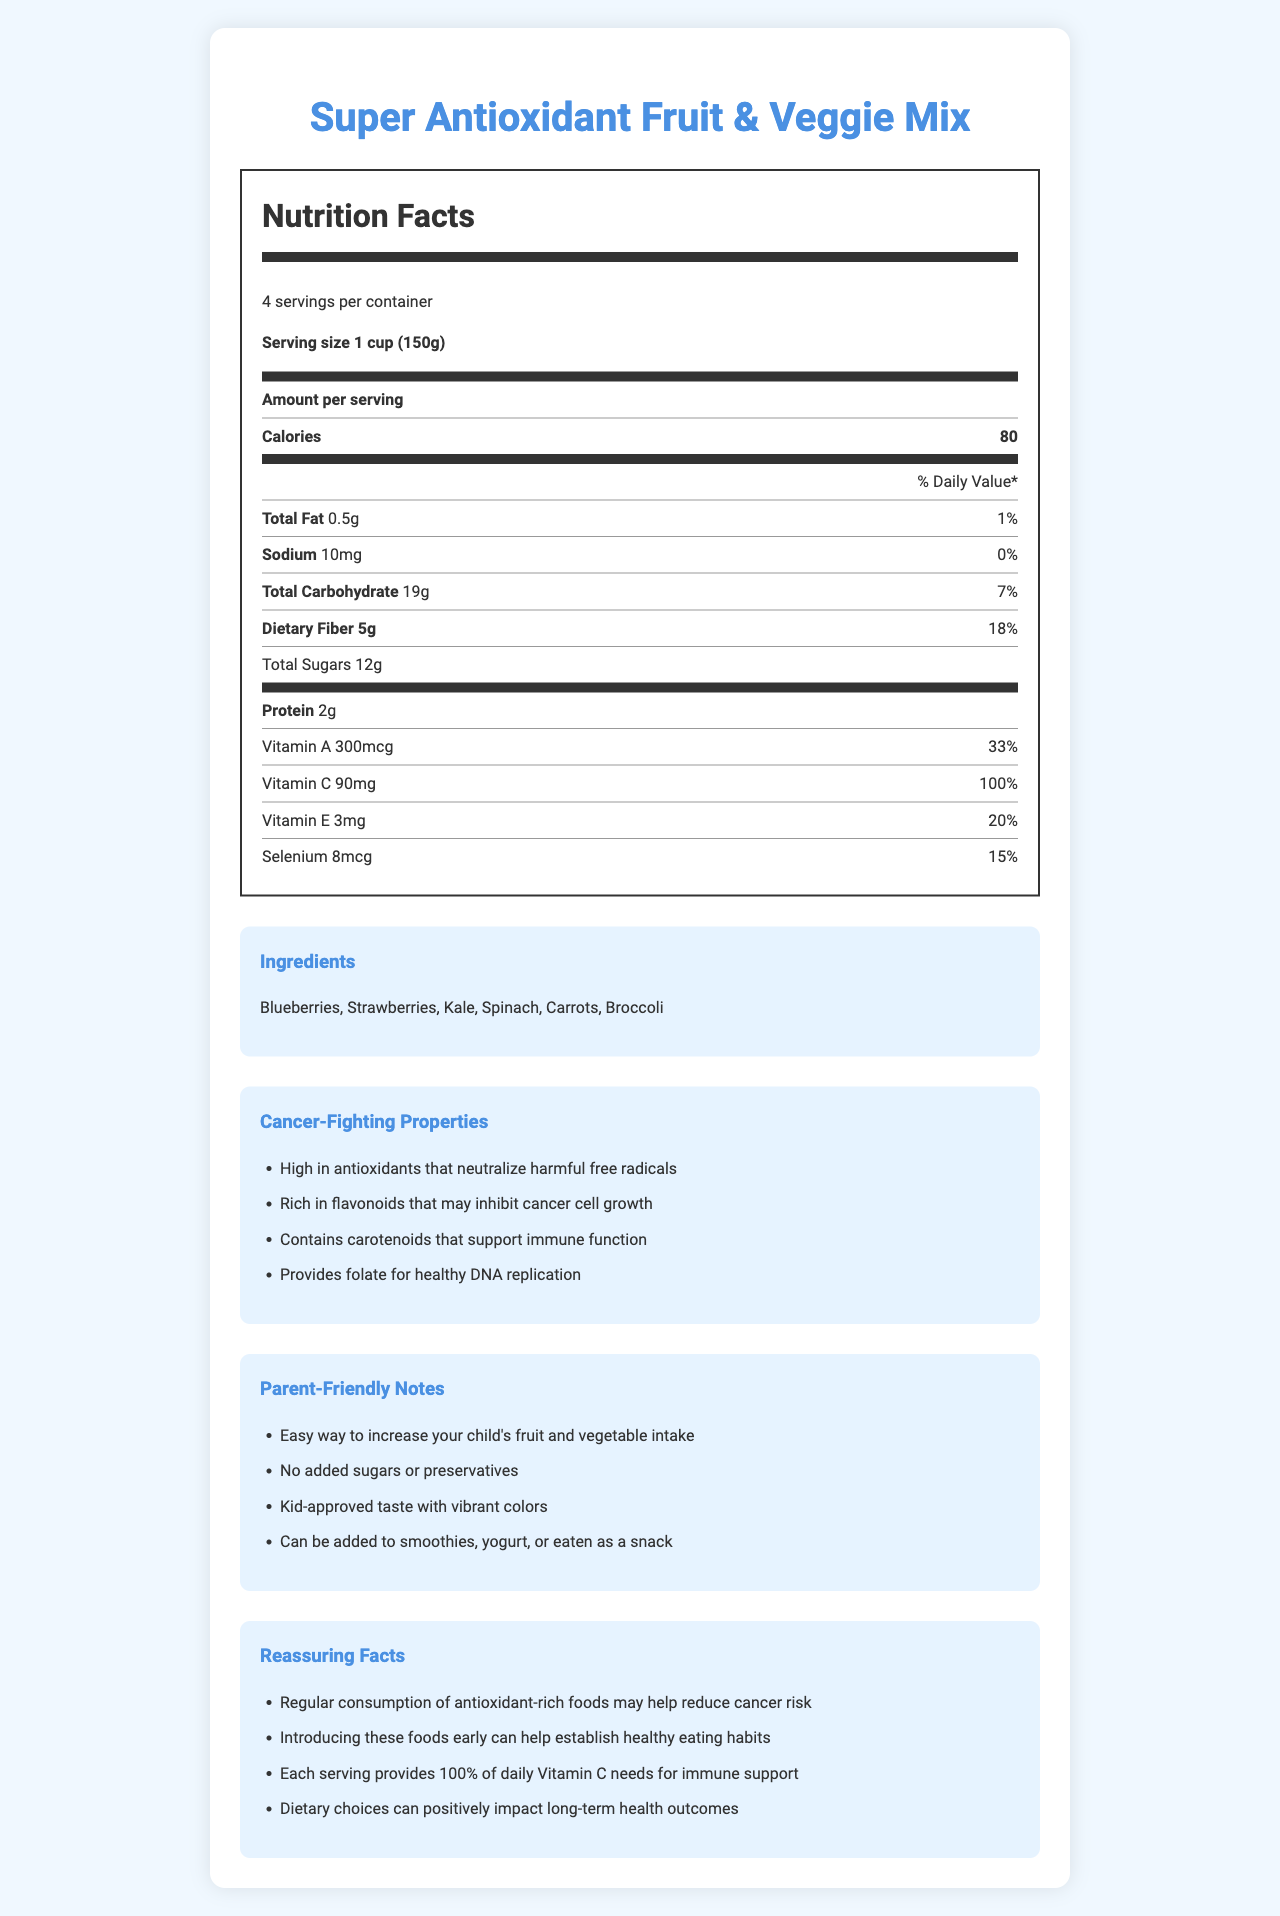how many servings are in a container? The document states that there are 4 servings per container.
Answer: 4 what is the serving size? The document specifies that each serving size is 1 cup (150g).
Answer: 1 cup (150g) how many calories are in one serving? The document shows that one serving contains 80 calories.
Answer: 80 which ingredient is listed first? The document lists the ingredients in the following order: Blueberries, Strawberries, Kale, Spinach, Carrots, Broccoli, indicating Blueberries are listed first.
Answer: Blueberries how much dietary fiber does one serving provide? The document indicates that each serving contains 5g of dietary fiber.
Answer: 5g what percentage of the daily value for Vitamin C does one serving provide? The document specifies that one serving provides 90mg of Vitamin C, which is 100% of the daily value.
Answer: 100% which vitamin has the highest daily value percentage in one serving? A. Vitamin A B. Vitamin C C. Vitamin E D. Selenium The document states that Vitamin C has a daily value percentage of 100%, which is the highest among the listed vitamins and minerals.
Answer: B. Vitamin C which of the following is not an ingredient in the product? A. Blueberries B. Kale C. Apples D. Carrots The document lists Blueberries, Kale, and Carrots, but not Apples.
Answer: C. Apples are there any added sugars or preservatives in the product? The document's "Parent-Friendly Notes" section states that there are no added sugars or preservatives.
Answer: No does regular consumption of antioxidant-rich foods help reduce cancer risk? The document's "Reassuring Facts" section mentions that regular consumption of antioxidant-rich foods may help reduce cancer risk.
Answer: Yes summarize the main idea of the document. The document details a healthy, antioxidant-rich fruit and veggie mix, focusing on its nutritional content, ingredients, and specific properties that may reduce cancer risk. It reassures parents about the product's safety and suitability for children and provides various consumption suggestions.
Answer: The document provides detailed nutrition information for "Super Antioxidant Fruit & Veggie Mix," emphasizing its health benefits, cancer-fighting properties, and suitability for children. It highlights key nutrients like Vitamins A, C, E, and Selenium and includes parent-friendly notes to reassure them about the product's quality and benefits. how much protein is in the entire container? The document provides the protein content per serving (2g), but it does not explicitly state the total protein content for the entire container. However, if inferred, it could be 2g x 4 servings = 8g.
Answer: Cannot be determined do antioxidant-rich foods support immune function? One of the cancer-fighting properties listed in the document is that antioxidant-rich foods support immune function by containing carotenoids.
Answer: Yes 